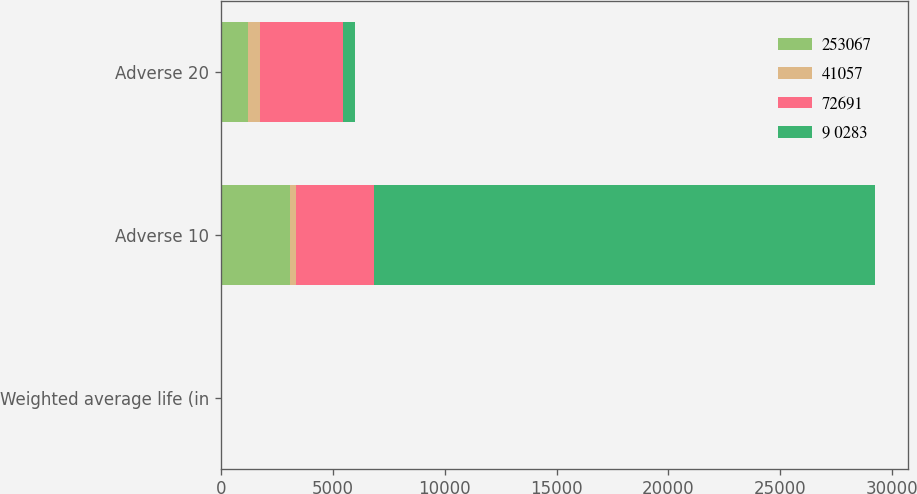Convert chart to OTSL. <chart><loc_0><loc_0><loc_500><loc_500><stacked_bar_chart><ecel><fcel>Weighted average life (in<fcel>Adverse 10<fcel>Adverse 20<nl><fcel>253067<fcel>5.7<fcel>3067<fcel>1186<nl><fcel>41057<fcel>2.4<fcel>263<fcel>545<nl><fcel>72691<fcel>4.1<fcel>3517<fcel>3735<nl><fcel>9 0283<fcel>1.4<fcel>22410<fcel>545<nl></chart> 